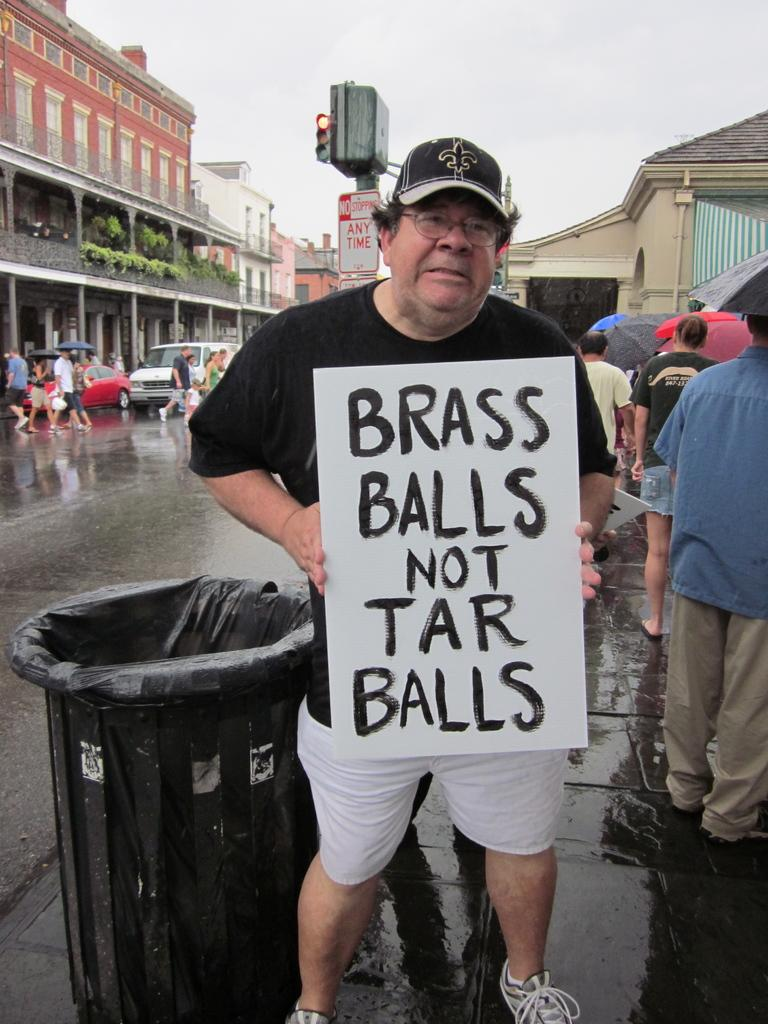<image>
Share a concise interpretation of the image provided. a man is holding a sign that says brass balls not tar balls 